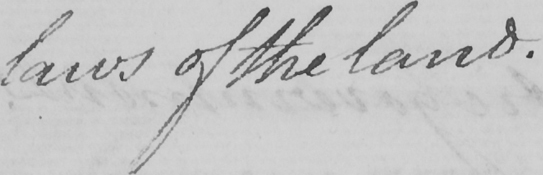Please provide the text content of this handwritten line. laws of the land . 